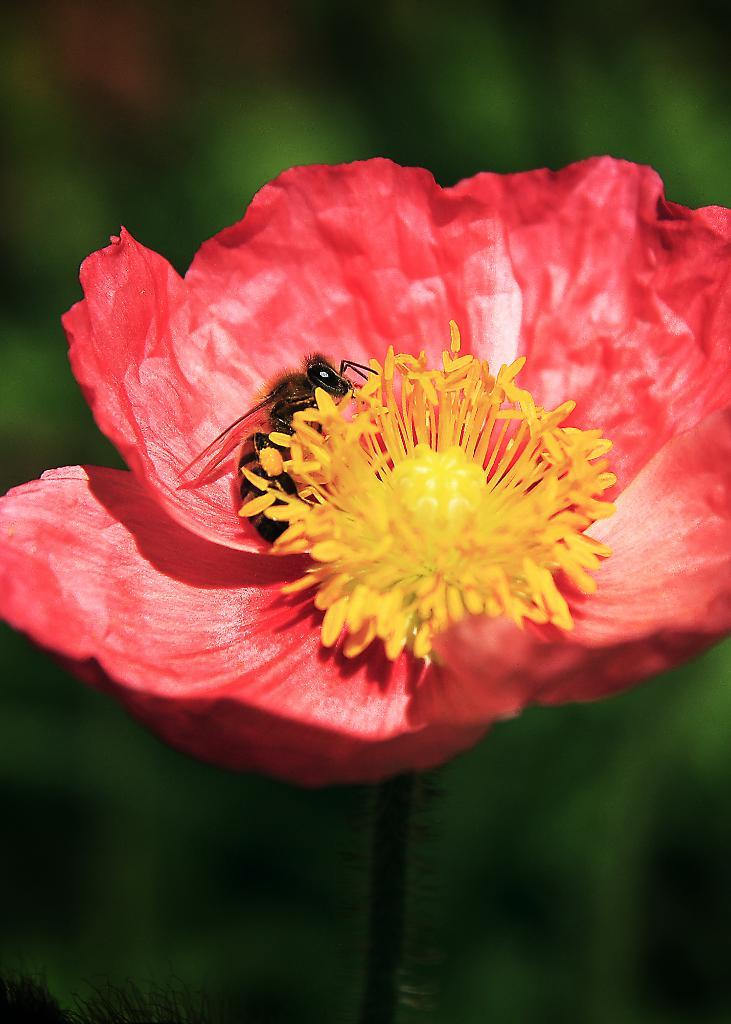What type of flower is in the image? There is a pink flower in the image. Is there any other living organism interacting with the flower? Yes, there is a honey bee on the flower. How would you describe the background of the image? The background of the image is blurred. What type of pleasure is the girl experiencing in the image? There is no girl present in the image, so it is not possible to determine what type of pleasure she might be experiencing. 